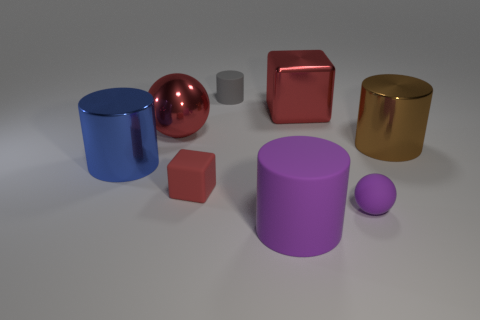Is the number of large red shiny cubes right of the big brown object greater than the number of blocks? When comparing the objects to the right of the big brown object (which is actually a cylinder), we find multiple shapes but only one large red shiny cube. There are several other blocks of different colors and shapes. So, the number of large red shiny cubes is not greater than the total number of blocks to its right. 